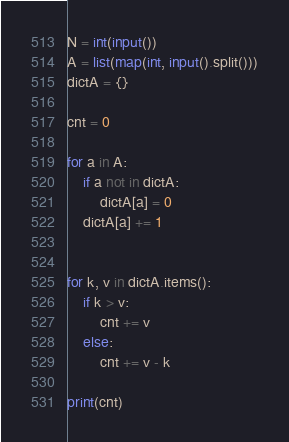<code> <loc_0><loc_0><loc_500><loc_500><_Python_>N = int(input())
A = list(map(int, input().split()))
dictA = {}

cnt = 0

for a in A:
    if a not in dictA:
        dictA[a] = 0
    dictA[a] += 1


for k, v in dictA.items():
    if k > v:
        cnt += v
    else:
        cnt += v - k

print(cnt)
</code> 